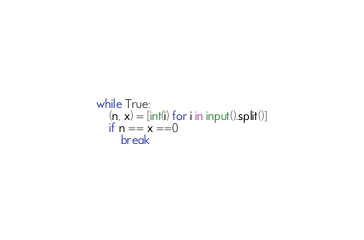Convert code to text. <code><loc_0><loc_0><loc_500><loc_500><_Python_>while True:
    (n, x) = [int(i) for i in input().split()]
    if n == x ==0
        break</code> 